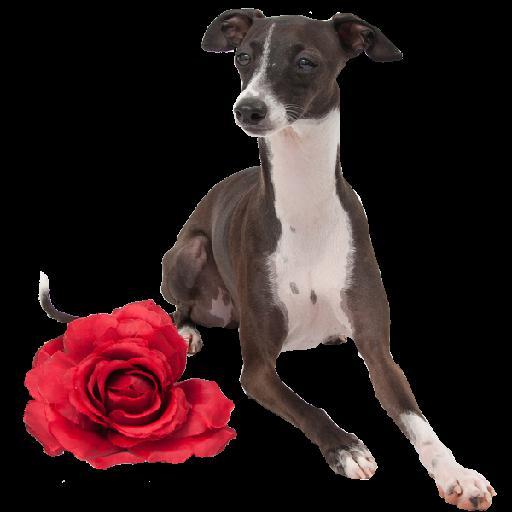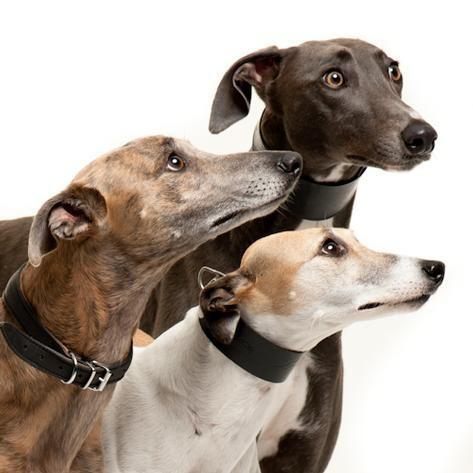The first image is the image on the left, the second image is the image on the right. Analyze the images presented: Is the assertion "There are six dogs in total." valid? Answer yes or no. No. The first image is the image on the left, the second image is the image on the right. Examine the images to the left and right. Is the description "Each image contains exactly three hounds, including one image of dogs posed in a horizontal row." accurate? Answer yes or no. No. 